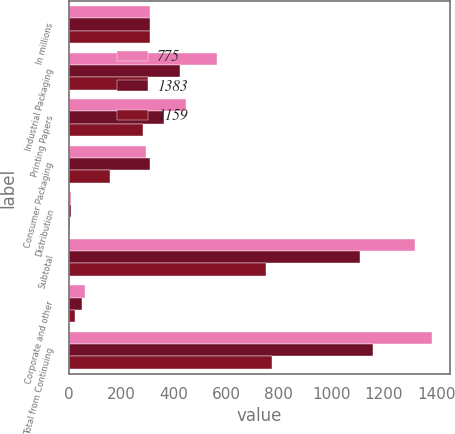<chart> <loc_0><loc_0><loc_500><loc_500><stacked_bar_chart><ecel><fcel>In millions<fcel>Industrial Packaging<fcel>Printing Papers<fcel>Consumer Packaging<fcel>Distribution<fcel>Subtotal<fcel>Corporate and other<fcel>Total from Continuing<nl><fcel>775<fcel>310<fcel>565<fcel>449<fcel>296<fcel>10<fcel>1320<fcel>63<fcel>1383<nl><fcel>1383<fcel>310<fcel>426<fcel>364<fcel>310<fcel>8<fcel>1108<fcel>51<fcel>1159<nl><fcel>1159<fcel>310<fcel>301<fcel>283<fcel>159<fcel>5<fcel>751<fcel>24<fcel>775<nl></chart> 